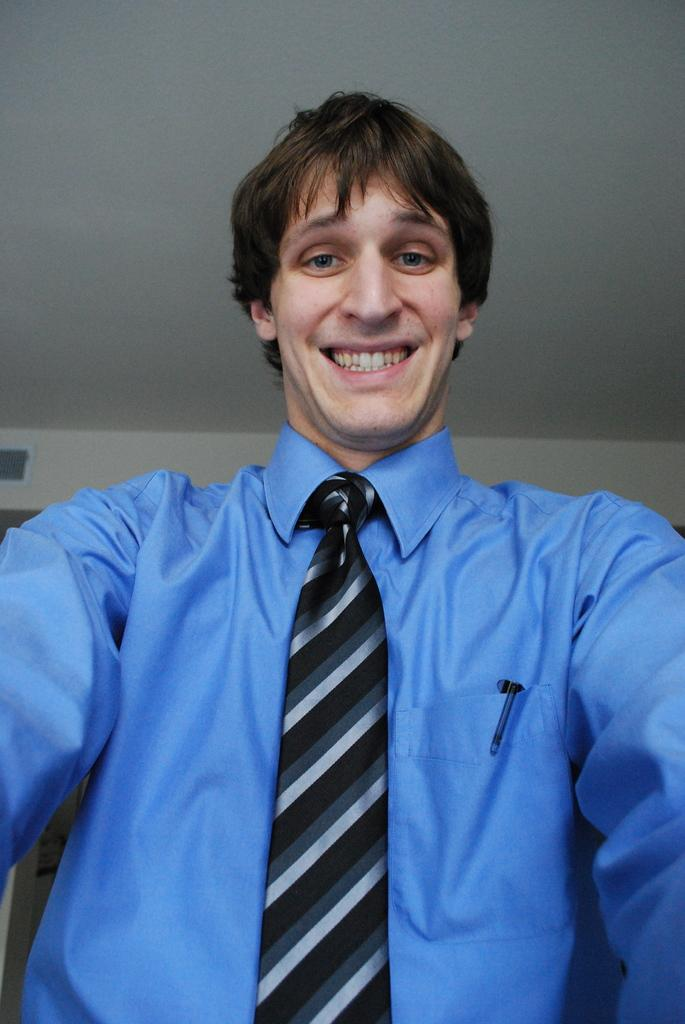Who or what is the main subject in the image? There is a person in the image. Can you describe the position of the person in the image? The person is standing in the middle of the image. What is the person wearing in the image? The person is wearing a blue color shirt. What can be seen in the background of the image? There is a wall in the background of the image. How many babies are comfortably sitting on a string in the image? There are no babies or strings present in the image. 